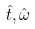<formula> <loc_0><loc_0><loc_500><loc_500>\hat { t } , \hat { \omega }</formula> 